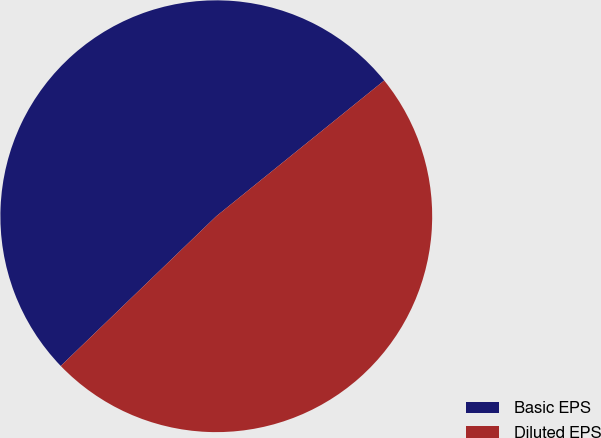Convert chart to OTSL. <chart><loc_0><loc_0><loc_500><loc_500><pie_chart><fcel>Basic EPS<fcel>Diluted EPS<nl><fcel>51.38%<fcel>48.62%<nl></chart> 